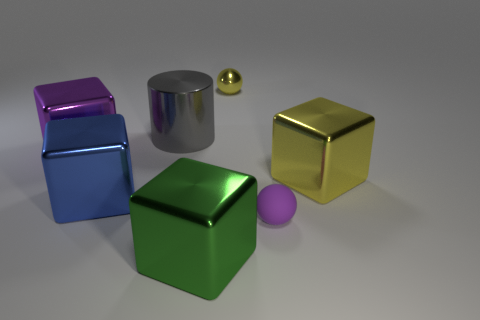Is there anything else that is made of the same material as the small purple object?
Keep it short and to the point. No. What number of other objects are there of the same shape as the big yellow metal thing?
Your answer should be compact. 3. Are any big matte blocks visible?
Make the answer very short. No. What number of objects are small yellow shiny spheres or metal things left of the purple rubber ball?
Your response must be concise. 5. Does the shiny block right of the green object have the same size as the green metallic block?
Offer a very short reply. Yes. How many other things are there of the same size as the blue metallic object?
Give a very brief answer. 4. The metallic sphere is what color?
Provide a succinct answer. Yellow. What is the material of the yellow object that is in front of the purple metallic object?
Your answer should be very brief. Metal. Is the number of green shiny things left of the gray metal cylinder the same as the number of gray matte blocks?
Your response must be concise. Yes. Is the shape of the small purple object the same as the tiny shiny object?
Your answer should be compact. Yes. 